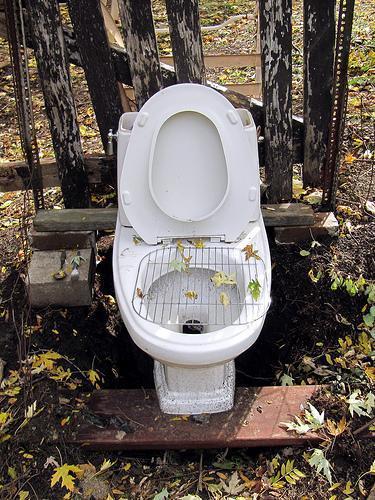How many toilet bowls are there?
Give a very brief answer. 1. 